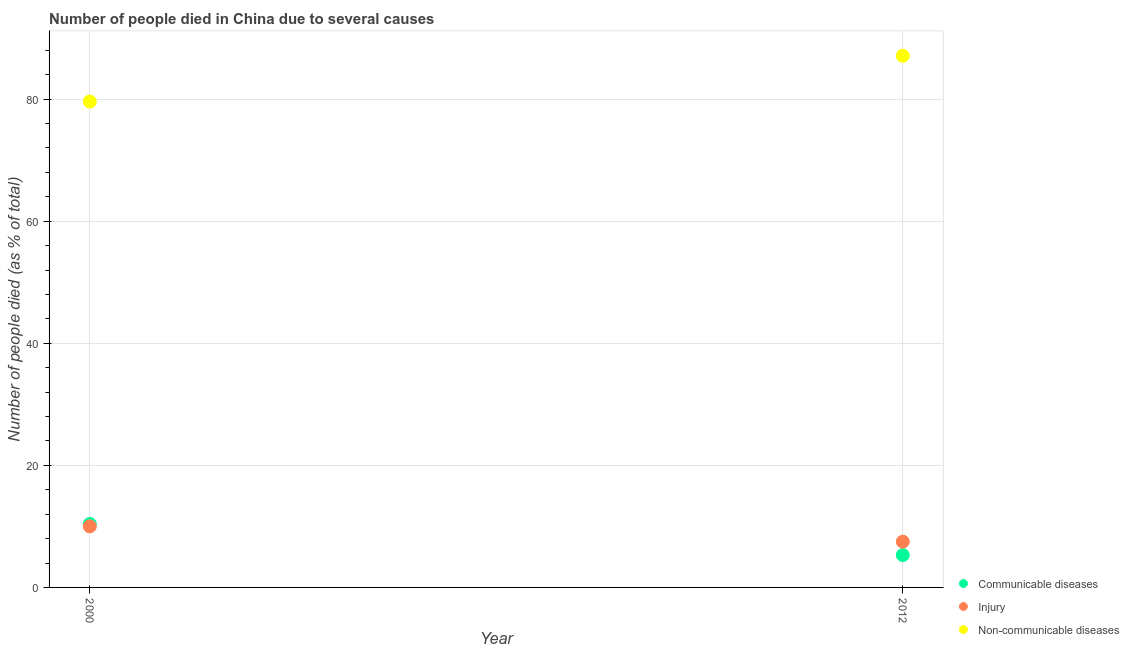How many different coloured dotlines are there?
Make the answer very short. 3. Is the number of dotlines equal to the number of legend labels?
Ensure brevity in your answer.  Yes. What is the number of people who died of injury in 2000?
Ensure brevity in your answer.  10. Across all years, what is the maximum number of people who dies of non-communicable diseases?
Provide a short and direct response. 87.1. In which year was the number of people who died of communicable diseases maximum?
Provide a succinct answer. 2000. What is the total number of people who died of communicable diseases in the graph?
Give a very brief answer. 15.7. What is the difference between the number of people who dies of non-communicable diseases in 2012 and the number of people who died of injury in 2000?
Your answer should be compact. 77.1. What is the average number of people who dies of non-communicable diseases per year?
Provide a short and direct response. 83.35. In the year 2000, what is the difference between the number of people who died of injury and number of people who died of communicable diseases?
Provide a succinct answer. -0.4. What is the ratio of the number of people who died of communicable diseases in 2000 to that in 2012?
Your answer should be compact. 1.96. In how many years, is the number of people who died of communicable diseases greater than the average number of people who died of communicable diseases taken over all years?
Ensure brevity in your answer.  1. Is it the case that in every year, the sum of the number of people who died of communicable diseases and number of people who died of injury is greater than the number of people who dies of non-communicable diseases?
Keep it short and to the point. No. Is the number of people who died of injury strictly greater than the number of people who dies of non-communicable diseases over the years?
Your response must be concise. No. How many dotlines are there?
Provide a succinct answer. 3. How many years are there in the graph?
Your answer should be very brief. 2. What is the difference between two consecutive major ticks on the Y-axis?
Keep it short and to the point. 20. Does the graph contain any zero values?
Provide a short and direct response. No. Does the graph contain grids?
Your answer should be compact. Yes. Where does the legend appear in the graph?
Provide a short and direct response. Bottom right. How many legend labels are there?
Provide a succinct answer. 3. What is the title of the graph?
Your answer should be very brief. Number of people died in China due to several causes. What is the label or title of the Y-axis?
Offer a terse response. Number of people died (as % of total). What is the Number of people died (as % of total) in Non-communicable diseases in 2000?
Offer a very short reply. 79.6. What is the Number of people died (as % of total) in Communicable diseases in 2012?
Your response must be concise. 5.3. What is the Number of people died (as % of total) of Injury in 2012?
Your response must be concise. 7.5. What is the Number of people died (as % of total) of Non-communicable diseases in 2012?
Give a very brief answer. 87.1. Across all years, what is the maximum Number of people died (as % of total) of Communicable diseases?
Your answer should be compact. 10.4. Across all years, what is the maximum Number of people died (as % of total) in Injury?
Make the answer very short. 10. Across all years, what is the maximum Number of people died (as % of total) in Non-communicable diseases?
Give a very brief answer. 87.1. Across all years, what is the minimum Number of people died (as % of total) in Communicable diseases?
Give a very brief answer. 5.3. Across all years, what is the minimum Number of people died (as % of total) in Non-communicable diseases?
Offer a very short reply. 79.6. What is the total Number of people died (as % of total) in Injury in the graph?
Offer a very short reply. 17.5. What is the total Number of people died (as % of total) in Non-communicable diseases in the graph?
Give a very brief answer. 166.7. What is the difference between the Number of people died (as % of total) of Injury in 2000 and that in 2012?
Give a very brief answer. 2.5. What is the difference between the Number of people died (as % of total) of Communicable diseases in 2000 and the Number of people died (as % of total) of Non-communicable diseases in 2012?
Offer a terse response. -76.7. What is the difference between the Number of people died (as % of total) of Injury in 2000 and the Number of people died (as % of total) of Non-communicable diseases in 2012?
Your answer should be compact. -77.1. What is the average Number of people died (as % of total) in Communicable diseases per year?
Your response must be concise. 7.85. What is the average Number of people died (as % of total) in Injury per year?
Make the answer very short. 8.75. What is the average Number of people died (as % of total) in Non-communicable diseases per year?
Offer a very short reply. 83.35. In the year 2000, what is the difference between the Number of people died (as % of total) of Communicable diseases and Number of people died (as % of total) of Injury?
Offer a terse response. 0.4. In the year 2000, what is the difference between the Number of people died (as % of total) in Communicable diseases and Number of people died (as % of total) in Non-communicable diseases?
Keep it short and to the point. -69.2. In the year 2000, what is the difference between the Number of people died (as % of total) in Injury and Number of people died (as % of total) in Non-communicable diseases?
Keep it short and to the point. -69.6. In the year 2012, what is the difference between the Number of people died (as % of total) of Communicable diseases and Number of people died (as % of total) of Non-communicable diseases?
Give a very brief answer. -81.8. In the year 2012, what is the difference between the Number of people died (as % of total) of Injury and Number of people died (as % of total) of Non-communicable diseases?
Make the answer very short. -79.6. What is the ratio of the Number of people died (as % of total) of Communicable diseases in 2000 to that in 2012?
Provide a short and direct response. 1.96. What is the ratio of the Number of people died (as % of total) in Non-communicable diseases in 2000 to that in 2012?
Your answer should be very brief. 0.91. What is the difference between the highest and the lowest Number of people died (as % of total) in Injury?
Keep it short and to the point. 2.5. What is the difference between the highest and the lowest Number of people died (as % of total) of Non-communicable diseases?
Offer a terse response. 7.5. 